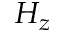Convert formula to latex. <formula><loc_0><loc_0><loc_500><loc_500>H _ { z }</formula> 